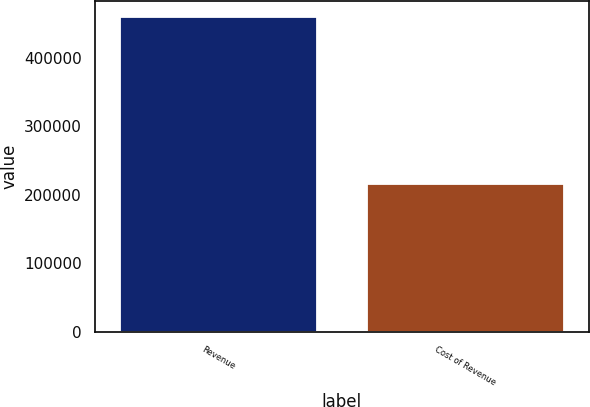Convert chart. <chart><loc_0><loc_0><loc_500><loc_500><bar_chart><fcel>Revenue<fcel>Cost of Revenue<nl><fcel>459779<fcel>215650<nl></chart> 